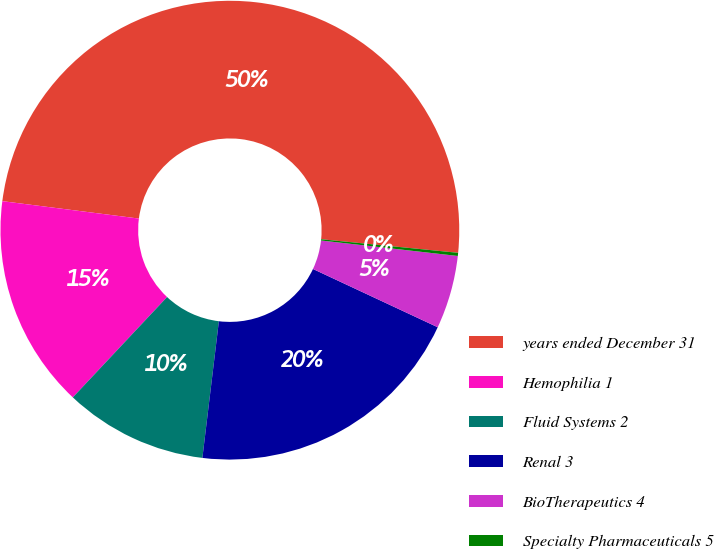<chart> <loc_0><loc_0><loc_500><loc_500><pie_chart><fcel>years ended December 31<fcel>Hemophilia 1<fcel>Fluid Systems 2<fcel>Renal 3<fcel>BioTherapeutics 4<fcel>Specialty Pharmaceuticals 5<nl><fcel>49.56%<fcel>15.02%<fcel>10.09%<fcel>19.96%<fcel>5.16%<fcel>0.22%<nl></chart> 